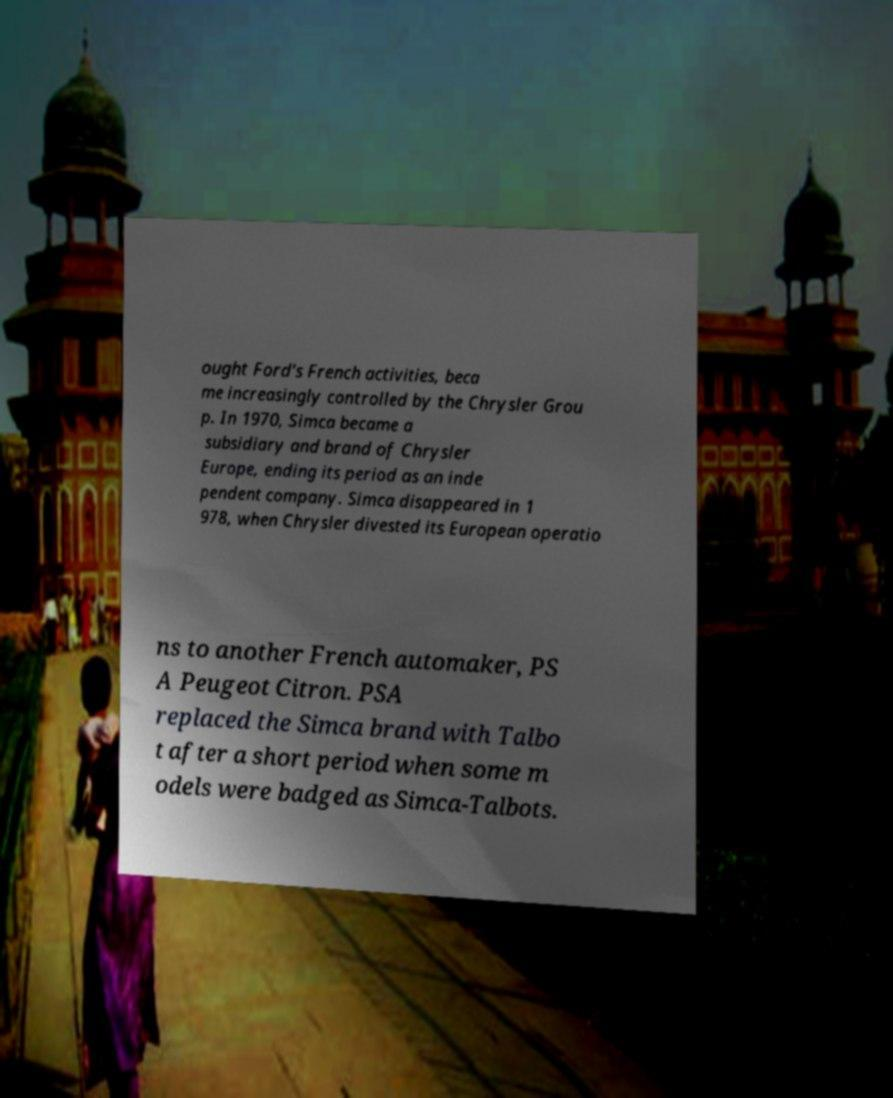I need the written content from this picture converted into text. Can you do that? ought Ford's French activities, beca me increasingly controlled by the Chrysler Grou p. In 1970, Simca became a subsidiary and brand of Chrysler Europe, ending its period as an inde pendent company. Simca disappeared in 1 978, when Chrysler divested its European operatio ns to another French automaker, PS A Peugeot Citron. PSA replaced the Simca brand with Talbo t after a short period when some m odels were badged as Simca-Talbots. 